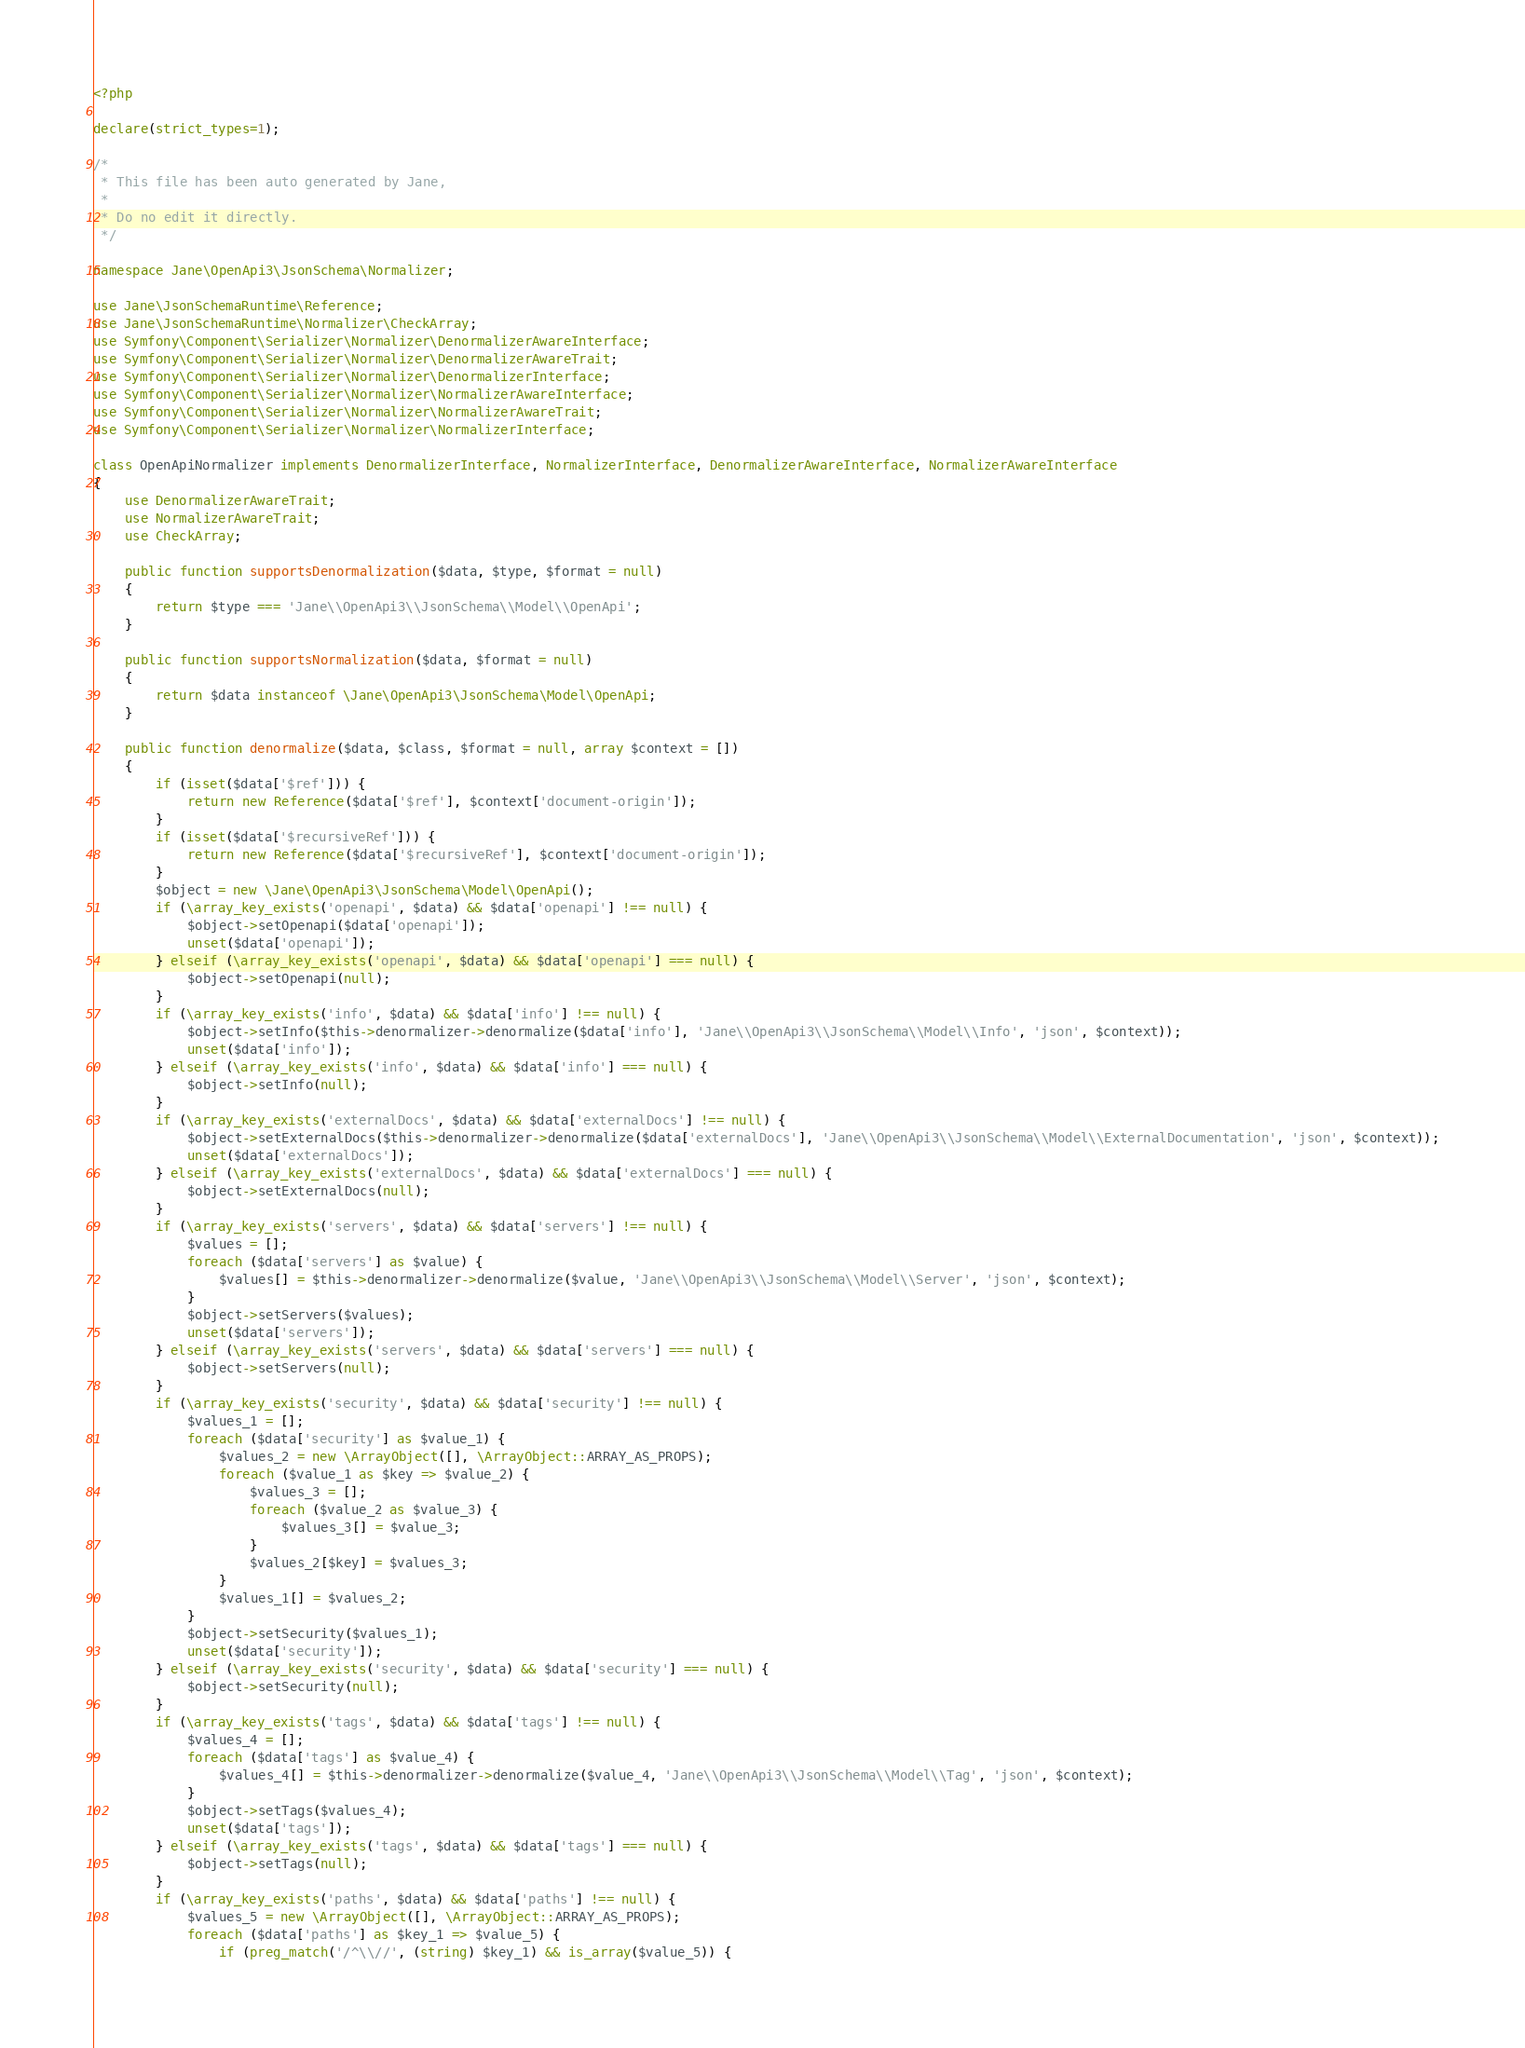Convert code to text. <code><loc_0><loc_0><loc_500><loc_500><_PHP_><?php

declare(strict_types=1);

/*
 * This file has been auto generated by Jane,
 *
 * Do no edit it directly.
 */

namespace Jane\OpenApi3\JsonSchema\Normalizer;

use Jane\JsonSchemaRuntime\Reference;
use Jane\JsonSchemaRuntime\Normalizer\CheckArray;
use Symfony\Component\Serializer\Normalizer\DenormalizerAwareInterface;
use Symfony\Component\Serializer\Normalizer\DenormalizerAwareTrait;
use Symfony\Component\Serializer\Normalizer\DenormalizerInterface;
use Symfony\Component\Serializer\Normalizer\NormalizerAwareInterface;
use Symfony\Component\Serializer\Normalizer\NormalizerAwareTrait;
use Symfony\Component\Serializer\Normalizer\NormalizerInterface;

class OpenApiNormalizer implements DenormalizerInterface, NormalizerInterface, DenormalizerAwareInterface, NormalizerAwareInterface
{
    use DenormalizerAwareTrait;
    use NormalizerAwareTrait;
    use CheckArray;

    public function supportsDenormalization($data, $type, $format = null)
    {
        return $type === 'Jane\\OpenApi3\\JsonSchema\\Model\\OpenApi';
    }

    public function supportsNormalization($data, $format = null)
    {
        return $data instanceof \Jane\OpenApi3\JsonSchema\Model\OpenApi;
    }

    public function denormalize($data, $class, $format = null, array $context = [])
    {
        if (isset($data['$ref'])) {
            return new Reference($data['$ref'], $context['document-origin']);
        }
        if (isset($data['$recursiveRef'])) {
            return new Reference($data['$recursiveRef'], $context['document-origin']);
        }
        $object = new \Jane\OpenApi3\JsonSchema\Model\OpenApi();
        if (\array_key_exists('openapi', $data) && $data['openapi'] !== null) {
            $object->setOpenapi($data['openapi']);
            unset($data['openapi']);
        } elseif (\array_key_exists('openapi', $data) && $data['openapi'] === null) {
            $object->setOpenapi(null);
        }
        if (\array_key_exists('info', $data) && $data['info'] !== null) {
            $object->setInfo($this->denormalizer->denormalize($data['info'], 'Jane\\OpenApi3\\JsonSchema\\Model\\Info', 'json', $context));
            unset($data['info']);
        } elseif (\array_key_exists('info', $data) && $data['info'] === null) {
            $object->setInfo(null);
        }
        if (\array_key_exists('externalDocs', $data) && $data['externalDocs'] !== null) {
            $object->setExternalDocs($this->denormalizer->denormalize($data['externalDocs'], 'Jane\\OpenApi3\\JsonSchema\\Model\\ExternalDocumentation', 'json', $context));
            unset($data['externalDocs']);
        } elseif (\array_key_exists('externalDocs', $data) && $data['externalDocs'] === null) {
            $object->setExternalDocs(null);
        }
        if (\array_key_exists('servers', $data) && $data['servers'] !== null) {
            $values = [];
            foreach ($data['servers'] as $value) {
                $values[] = $this->denormalizer->denormalize($value, 'Jane\\OpenApi3\\JsonSchema\\Model\\Server', 'json', $context);
            }
            $object->setServers($values);
            unset($data['servers']);
        } elseif (\array_key_exists('servers', $data) && $data['servers'] === null) {
            $object->setServers(null);
        }
        if (\array_key_exists('security', $data) && $data['security'] !== null) {
            $values_1 = [];
            foreach ($data['security'] as $value_1) {
                $values_2 = new \ArrayObject([], \ArrayObject::ARRAY_AS_PROPS);
                foreach ($value_1 as $key => $value_2) {
                    $values_3 = [];
                    foreach ($value_2 as $value_3) {
                        $values_3[] = $value_3;
                    }
                    $values_2[$key] = $values_3;
                }
                $values_1[] = $values_2;
            }
            $object->setSecurity($values_1);
            unset($data['security']);
        } elseif (\array_key_exists('security', $data) && $data['security'] === null) {
            $object->setSecurity(null);
        }
        if (\array_key_exists('tags', $data) && $data['tags'] !== null) {
            $values_4 = [];
            foreach ($data['tags'] as $value_4) {
                $values_4[] = $this->denormalizer->denormalize($value_4, 'Jane\\OpenApi3\\JsonSchema\\Model\\Tag', 'json', $context);
            }
            $object->setTags($values_4);
            unset($data['tags']);
        } elseif (\array_key_exists('tags', $data) && $data['tags'] === null) {
            $object->setTags(null);
        }
        if (\array_key_exists('paths', $data) && $data['paths'] !== null) {
            $values_5 = new \ArrayObject([], \ArrayObject::ARRAY_AS_PROPS);
            foreach ($data['paths'] as $key_1 => $value_5) {
                if (preg_match('/^\\//', (string) $key_1) && is_array($value_5)) {</code> 